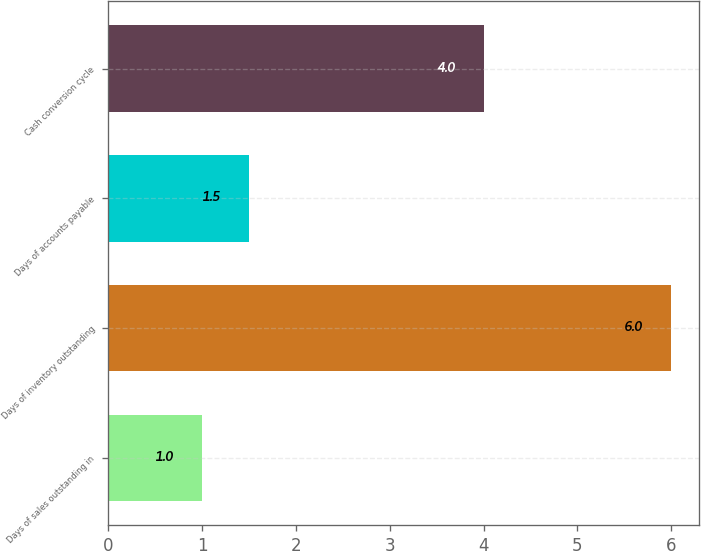<chart> <loc_0><loc_0><loc_500><loc_500><bar_chart><fcel>Days of sales outstanding in<fcel>Days of inventory outstanding<fcel>Days of accounts payable<fcel>Cash conversion cycle<nl><fcel>1<fcel>6<fcel>1.5<fcel>4<nl></chart> 